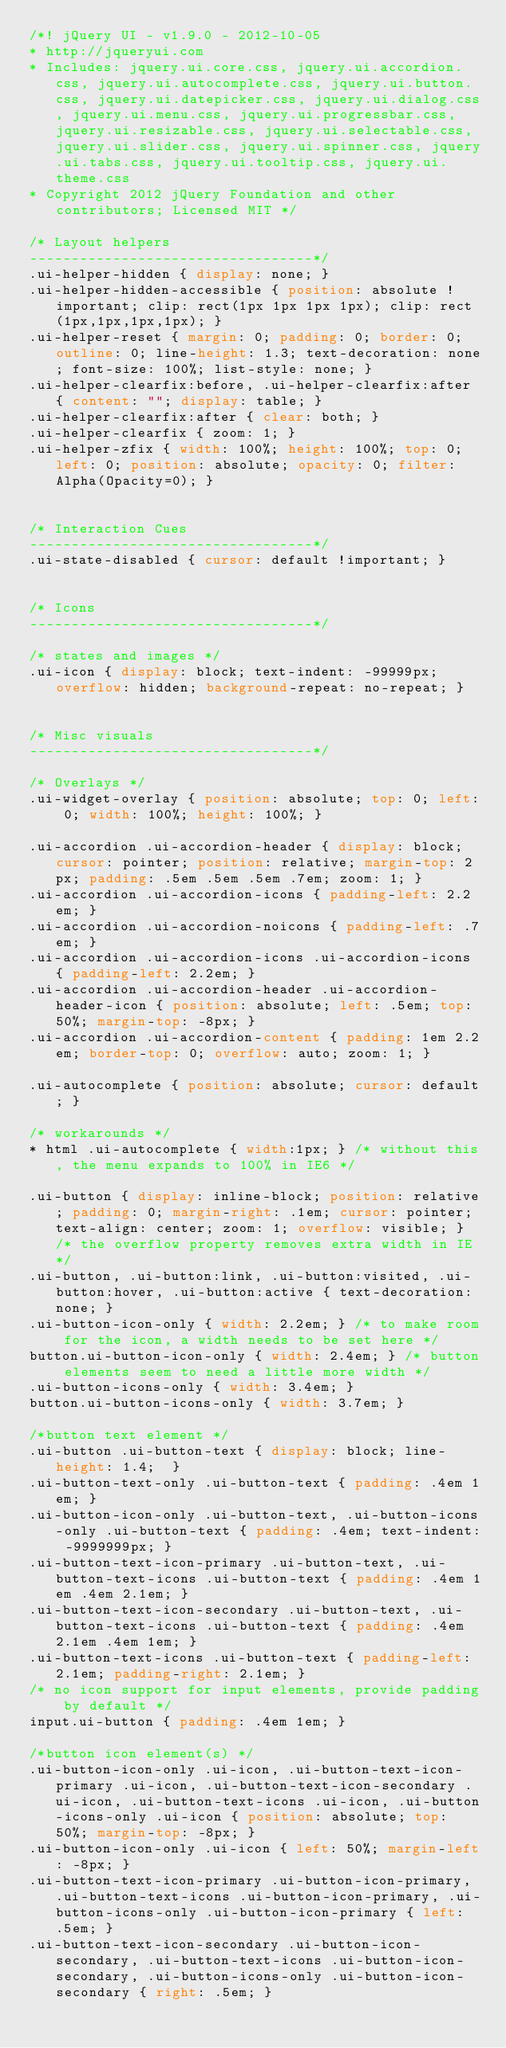<code> <loc_0><loc_0><loc_500><loc_500><_CSS_>/*! jQuery UI - v1.9.0 - 2012-10-05
* http://jqueryui.com
* Includes: jquery.ui.core.css, jquery.ui.accordion.css, jquery.ui.autocomplete.css, jquery.ui.button.css, jquery.ui.datepicker.css, jquery.ui.dialog.css, jquery.ui.menu.css, jquery.ui.progressbar.css, jquery.ui.resizable.css, jquery.ui.selectable.css, jquery.ui.slider.css, jquery.ui.spinner.css, jquery.ui.tabs.css, jquery.ui.tooltip.css, jquery.ui.theme.css
* Copyright 2012 jQuery Foundation and other contributors; Licensed MIT */

/* Layout helpers
----------------------------------*/
.ui-helper-hidden { display: none; }
.ui-helper-hidden-accessible { position: absolute !important; clip: rect(1px 1px 1px 1px); clip: rect(1px,1px,1px,1px); }
.ui-helper-reset { margin: 0; padding: 0; border: 0; outline: 0; line-height: 1.3; text-decoration: none; font-size: 100%; list-style: none; }
.ui-helper-clearfix:before, .ui-helper-clearfix:after { content: ""; display: table; }
.ui-helper-clearfix:after { clear: both; }
.ui-helper-clearfix { zoom: 1; }
.ui-helper-zfix { width: 100%; height: 100%; top: 0; left: 0; position: absolute; opacity: 0; filter:Alpha(Opacity=0); }


/* Interaction Cues
----------------------------------*/
.ui-state-disabled { cursor: default !important; }


/* Icons
----------------------------------*/

/* states and images */
.ui-icon { display: block; text-indent: -99999px; overflow: hidden; background-repeat: no-repeat; }


/* Misc visuals
----------------------------------*/

/* Overlays */
.ui-widget-overlay { position: absolute; top: 0; left: 0; width: 100%; height: 100%; }

.ui-accordion .ui-accordion-header { display: block; cursor: pointer; position: relative; margin-top: 2px; padding: .5em .5em .5em .7em; zoom: 1; }
.ui-accordion .ui-accordion-icons { padding-left: 2.2em; }
.ui-accordion .ui-accordion-noicons { padding-left: .7em; }
.ui-accordion .ui-accordion-icons .ui-accordion-icons { padding-left: 2.2em; }
.ui-accordion .ui-accordion-header .ui-accordion-header-icon { position: absolute; left: .5em; top: 50%; margin-top: -8px; }
.ui-accordion .ui-accordion-content { padding: 1em 2.2em; border-top: 0; overflow: auto; zoom: 1; }

.ui-autocomplete { position: absolute; cursor: default; }	

/* workarounds */
* html .ui-autocomplete { width:1px; } /* without this, the menu expands to 100% in IE6 */

.ui-button { display: inline-block; position: relative; padding: 0; margin-right: .1em; cursor: pointer; text-align: center; zoom: 1; overflow: visible; } /* the overflow property removes extra width in IE */
.ui-button, .ui-button:link, .ui-button:visited, .ui-button:hover, .ui-button:active { text-decoration: none; }
.ui-button-icon-only { width: 2.2em; } /* to make room for the icon, a width needs to be set here */
button.ui-button-icon-only { width: 2.4em; } /* button elements seem to need a little more width */
.ui-button-icons-only { width: 3.4em; } 
button.ui-button-icons-only { width: 3.7em; } 

/*button text element */
.ui-button .ui-button-text { display: block; line-height: 1.4;  }
.ui-button-text-only .ui-button-text { padding: .4em 1em; }
.ui-button-icon-only .ui-button-text, .ui-button-icons-only .ui-button-text { padding: .4em; text-indent: -9999999px; }
.ui-button-text-icon-primary .ui-button-text, .ui-button-text-icons .ui-button-text { padding: .4em 1em .4em 2.1em; }
.ui-button-text-icon-secondary .ui-button-text, .ui-button-text-icons .ui-button-text { padding: .4em 2.1em .4em 1em; }
.ui-button-text-icons .ui-button-text { padding-left: 2.1em; padding-right: 2.1em; }
/* no icon support for input elements, provide padding by default */
input.ui-button { padding: .4em 1em; }

/*button icon element(s) */
.ui-button-icon-only .ui-icon, .ui-button-text-icon-primary .ui-icon, .ui-button-text-icon-secondary .ui-icon, .ui-button-text-icons .ui-icon, .ui-button-icons-only .ui-icon { position: absolute; top: 50%; margin-top: -8px; }
.ui-button-icon-only .ui-icon { left: 50%; margin-left: -8px; }
.ui-button-text-icon-primary .ui-button-icon-primary, .ui-button-text-icons .ui-button-icon-primary, .ui-button-icons-only .ui-button-icon-primary { left: .5em; }
.ui-button-text-icon-secondary .ui-button-icon-secondary, .ui-button-text-icons .ui-button-icon-secondary, .ui-button-icons-only .ui-button-icon-secondary { right: .5em; }</code> 